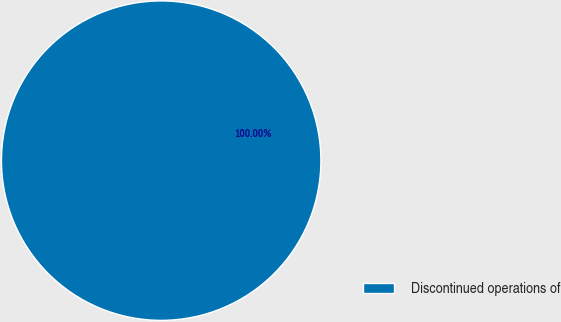<chart> <loc_0><loc_0><loc_500><loc_500><pie_chart><fcel>Discontinued operations of<nl><fcel>100.0%<nl></chart> 